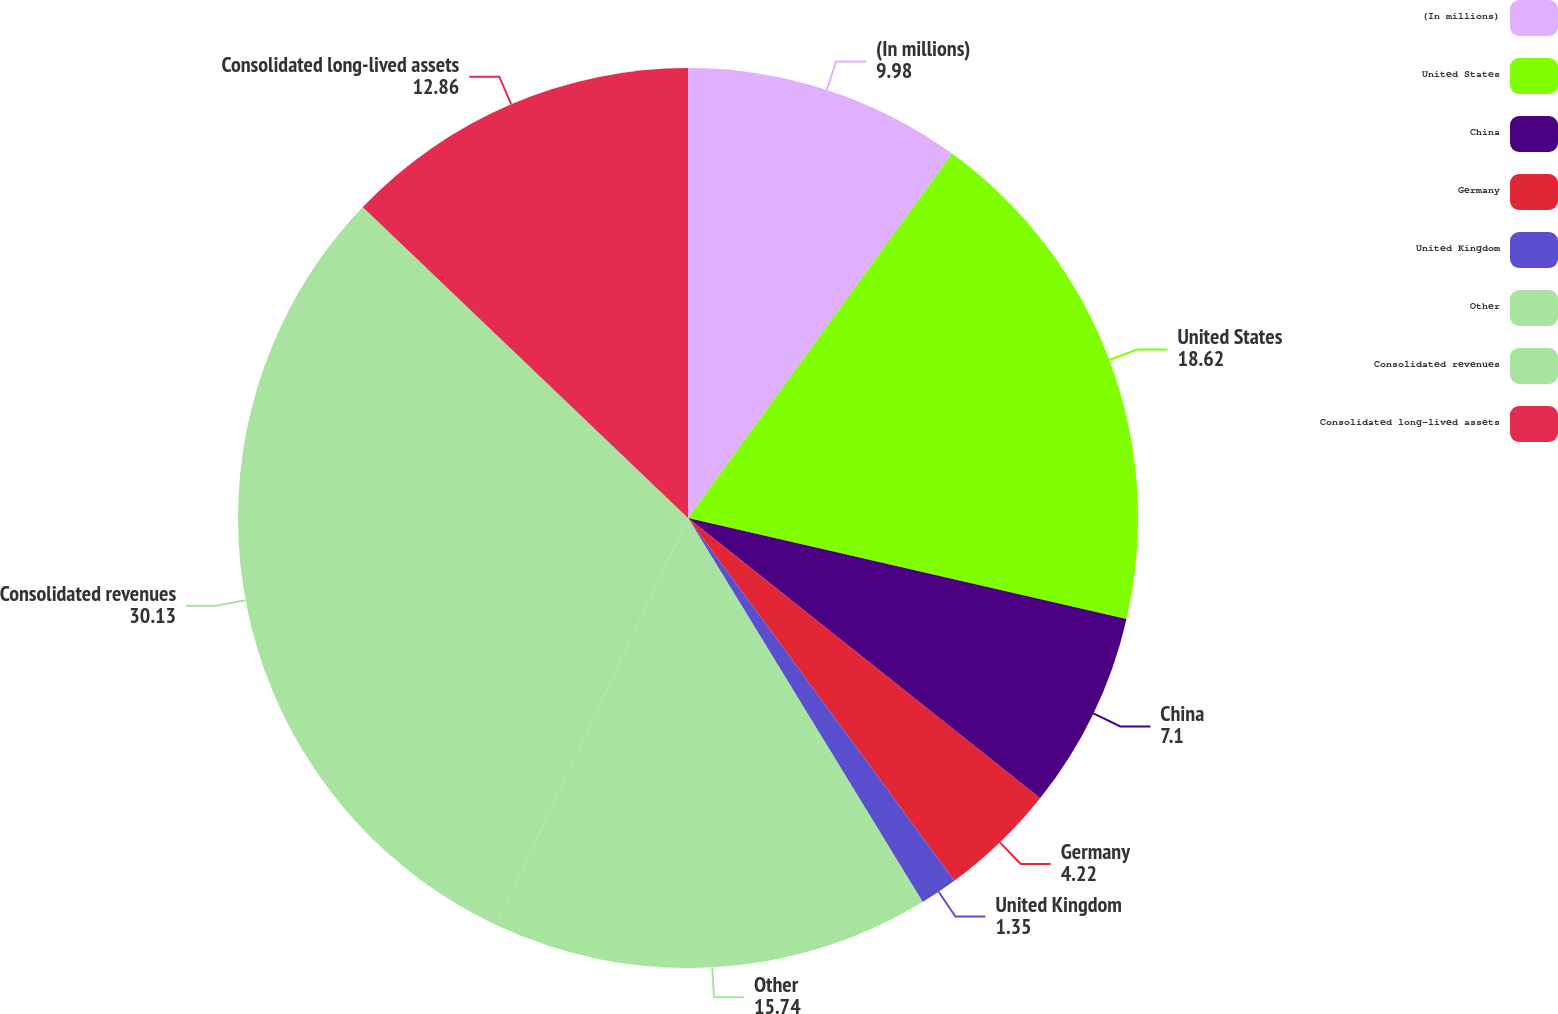Convert chart to OTSL. <chart><loc_0><loc_0><loc_500><loc_500><pie_chart><fcel>(In millions)<fcel>United States<fcel>China<fcel>Germany<fcel>United Kingdom<fcel>Other<fcel>Consolidated revenues<fcel>Consolidated long-lived assets<nl><fcel>9.98%<fcel>18.62%<fcel>7.1%<fcel>4.22%<fcel>1.35%<fcel>15.74%<fcel>30.13%<fcel>12.86%<nl></chart> 